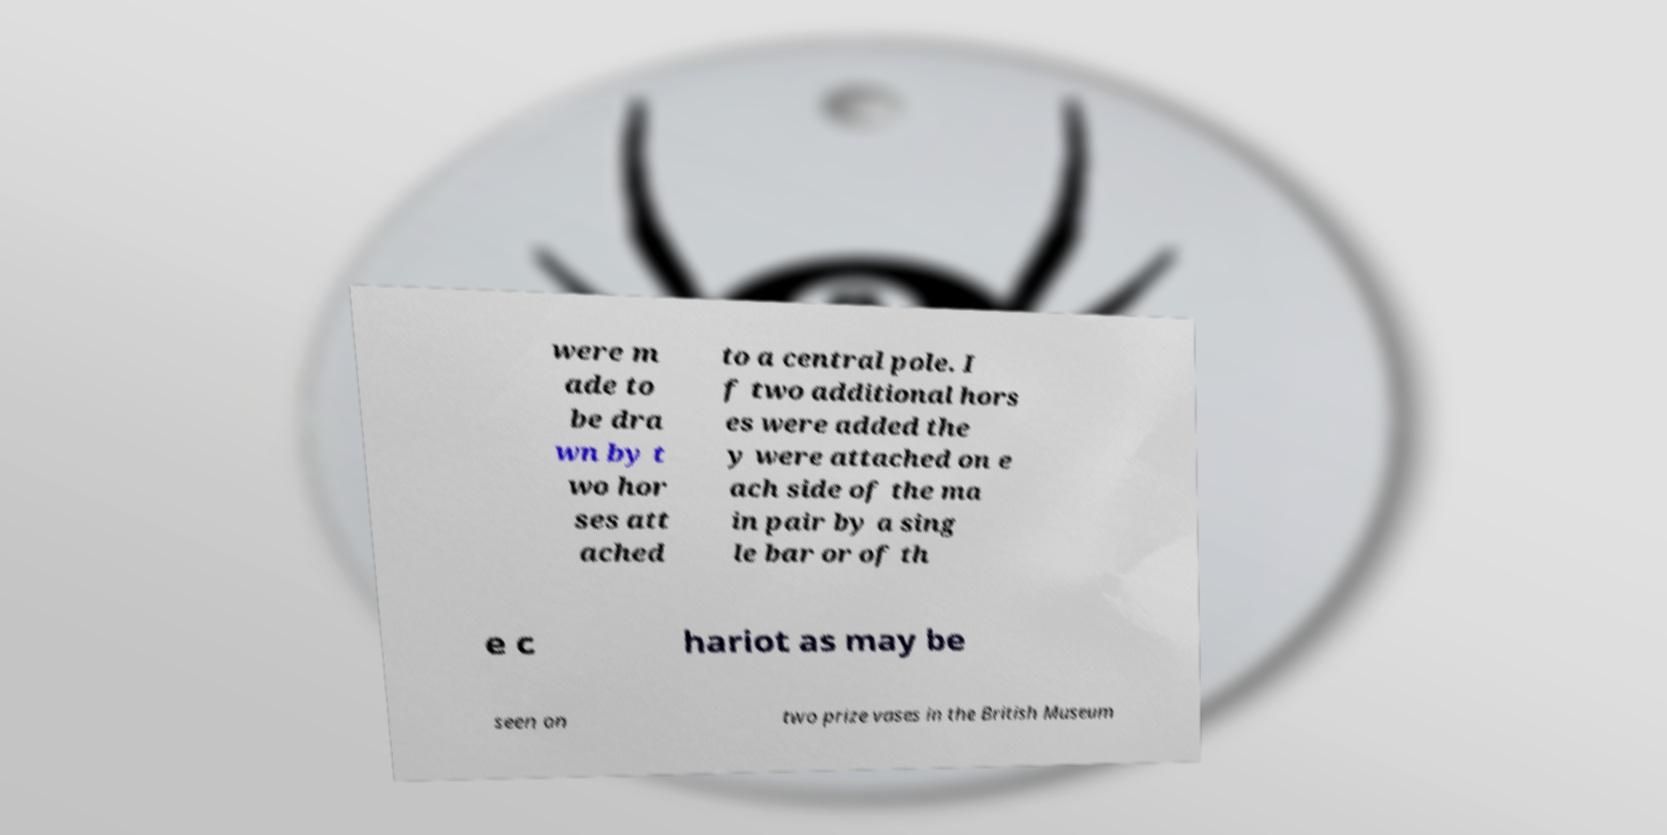Can you accurately transcribe the text from the provided image for me? were m ade to be dra wn by t wo hor ses att ached to a central pole. I f two additional hors es were added the y were attached on e ach side of the ma in pair by a sing le bar or of th e c hariot as may be seen on two prize vases in the British Museum 